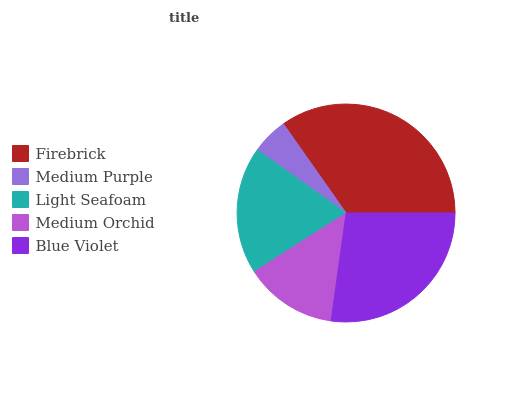Is Medium Purple the minimum?
Answer yes or no. Yes. Is Firebrick the maximum?
Answer yes or no. Yes. Is Light Seafoam the minimum?
Answer yes or no. No. Is Light Seafoam the maximum?
Answer yes or no. No. Is Light Seafoam greater than Medium Purple?
Answer yes or no. Yes. Is Medium Purple less than Light Seafoam?
Answer yes or no. Yes. Is Medium Purple greater than Light Seafoam?
Answer yes or no. No. Is Light Seafoam less than Medium Purple?
Answer yes or no. No. Is Light Seafoam the high median?
Answer yes or no. Yes. Is Light Seafoam the low median?
Answer yes or no. Yes. Is Blue Violet the high median?
Answer yes or no. No. Is Firebrick the low median?
Answer yes or no. No. 